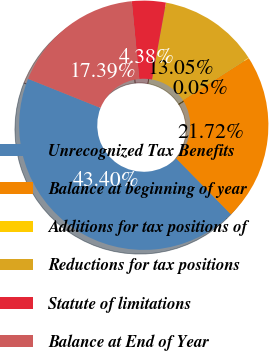Convert chart to OTSL. <chart><loc_0><loc_0><loc_500><loc_500><pie_chart><fcel>Unrecognized Tax Benefits<fcel>Balance at beginning of year<fcel>Additions for tax positions of<fcel>Reductions for tax positions<fcel>Statute of limitations<fcel>Balance at End of Year<nl><fcel>43.4%<fcel>21.72%<fcel>0.05%<fcel>13.05%<fcel>4.38%<fcel>17.39%<nl></chart> 